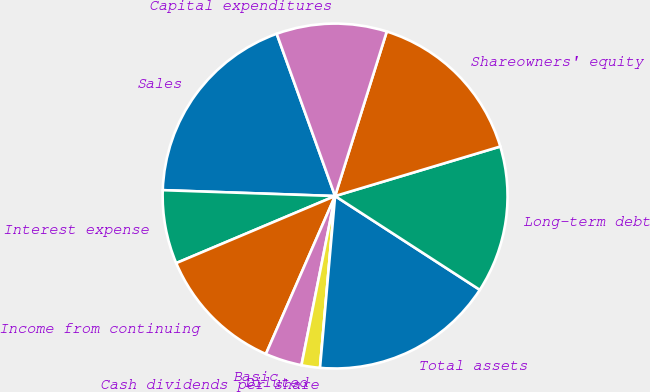<chart> <loc_0><loc_0><loc_500><loc_500><pie_chart><fcel>Sales<fcel>Interest expense<fcel>Income from continuing<fcel>Basic<fcel>Diluted<fcel>Cash dividends per share<fcel>Total assets<fcel>Long-term debt<fcel>Shareowners' equity<fcel>Capital expenditures<nl><fcel>18.96%<fcel>6.9%<fcel>12.07%<fcel>3.45%<fcel>1.73%<fcel>0.0%<fcel>17.24%<fcel>13.79%<fcel>15.52%<fcel>10.34%<nl></chart> 